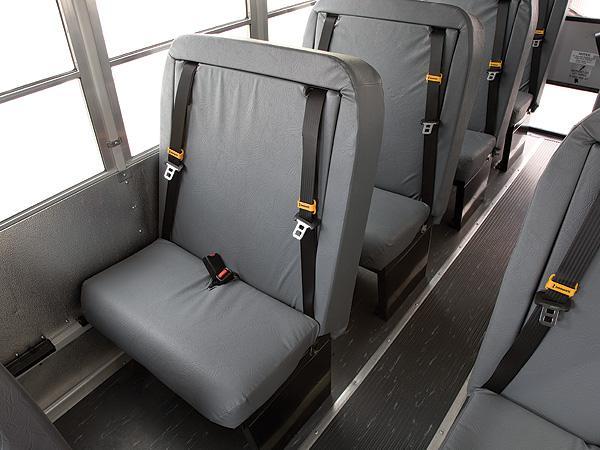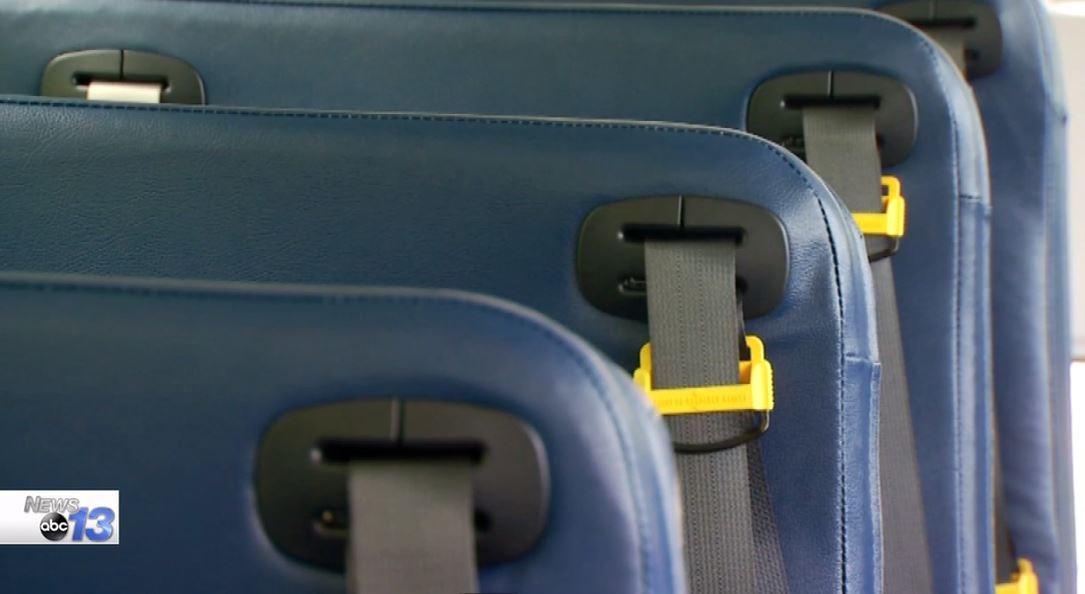The first image is the image on the left, the second image is the image on the right. For the images shown, is this caption "The left image shows an empty gray seat with two seat buckles and straps on the seat back." true? Answer yes or no. Yes. 